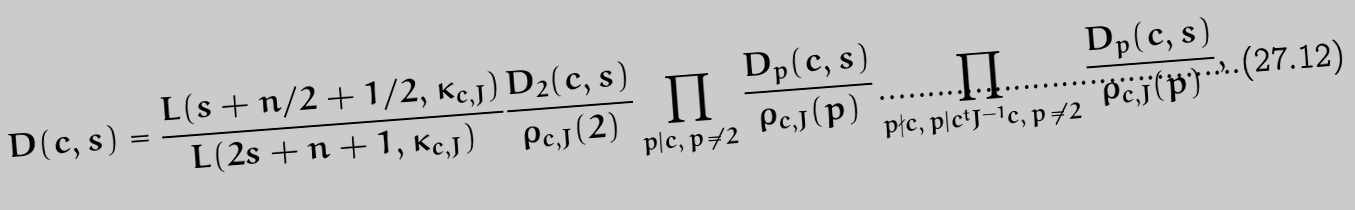<formula> <loc_0><loc_0><loc_500><loc_500>D ( c , s ) = \frac { L ( s + n / 2 + 1 / 2 , \kappa _ { c , J } ) } { L ( 2 s + n + 1 , \kappa _ { c , J } ) } \frac { D _ { 2 } ( c , s ) } { \rho _ { c , J } ( 2 ) } \prod _ { p | c , \, p \, \neq \, 2 } \frac { D _ { p } ( c , s ) } { \rho _ { c , J } ( p ) } \prod _ { p \nmid c , \, p | c ^ { t } J ^ { - 1 } c , \, p \, \neq \, 2 } \frac { D _ { p } ( c , s ) } { \rho _ { c , J } ( p ) } ,</formula> 